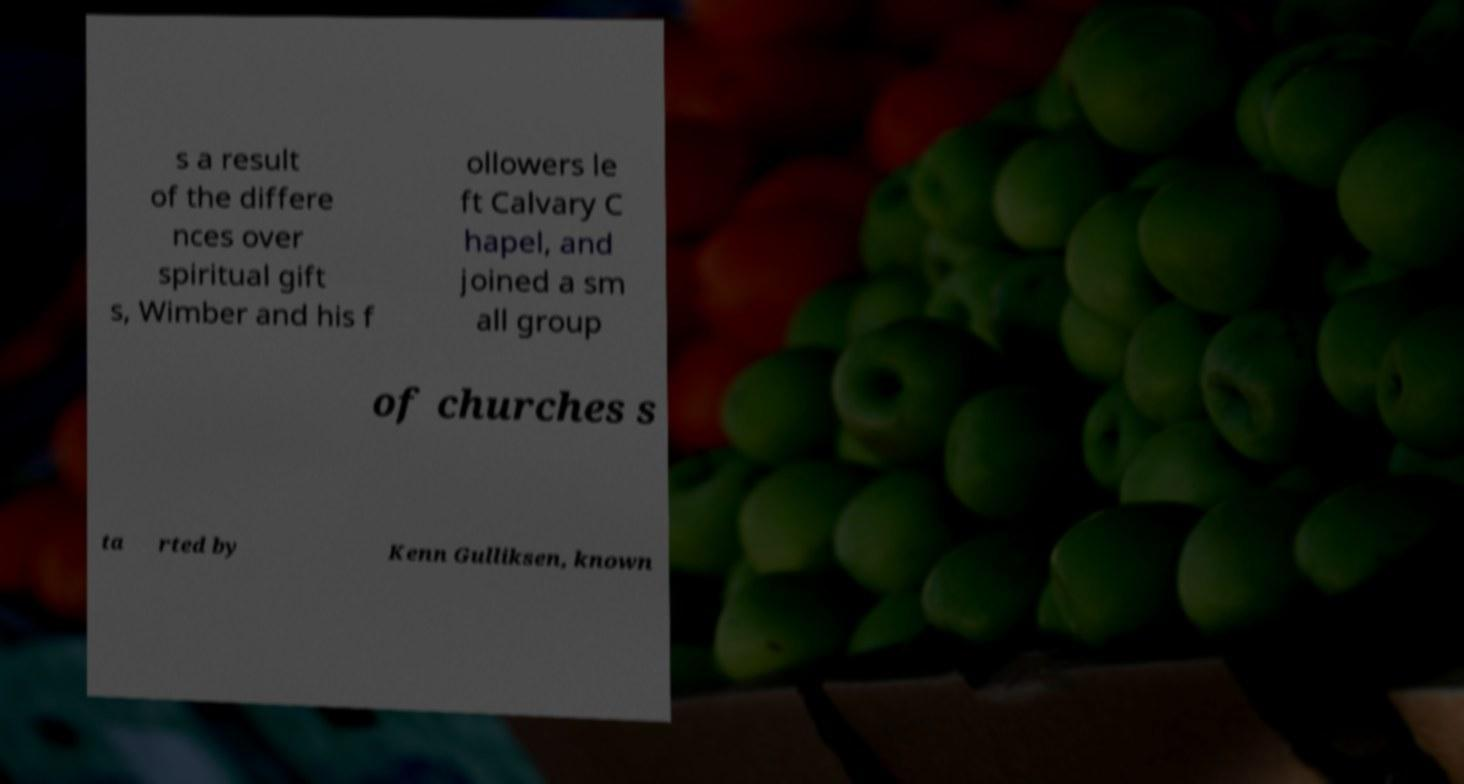Can you read and provide the text displayed in the image?This photo seems to have some interesting text. Can you extract and type it out for me? s a result of the differe nces over spiritual gift s, Wimber and his f ollowers le ft Calvary C hapel, and joined a sm all group of churches s ta rted by Kenn Gulliksen, known 